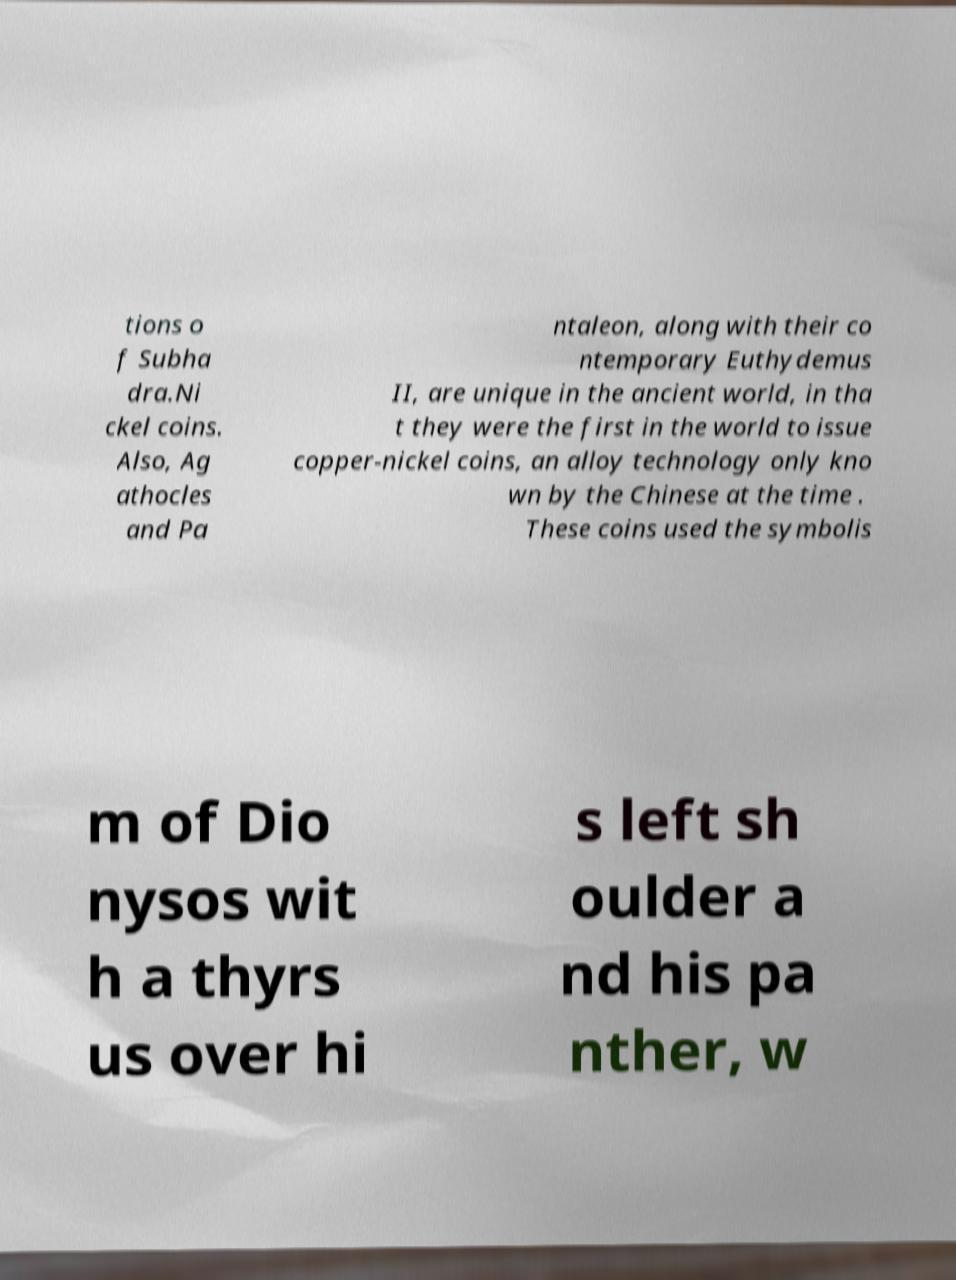Can you read and provide the text displayed in the image?This photo seems to have some interesting text. Can you extract and type it out for me? tions o f Subha dra.Ni ckel coins. Also, Ag athocles and Pa ntaleon, along with their co ntemporary Euthydemus II, are unique in the ancient world, in tha t they were the first in the world to issue copper-nickel coins, an alloy technology only kno wn by the Chinese at the time . These coins used the symbolis m of Dio nysos wit h a thyrs us over hi s left sh oulder a nd his pa nther, w 